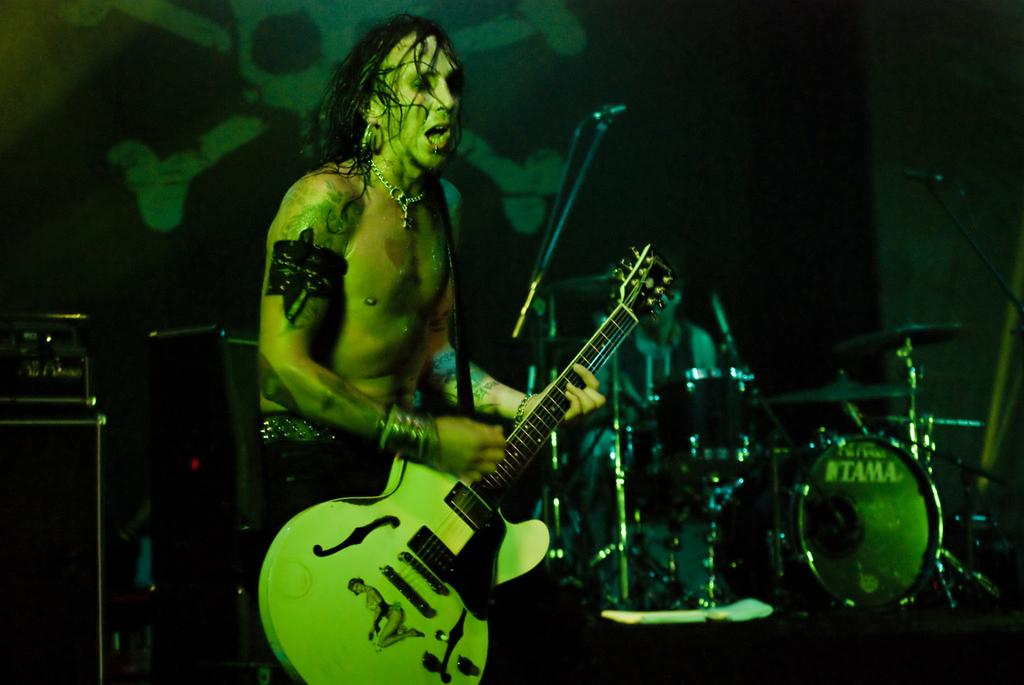What is the man in the image doing? The man in the image is playing a guitar. Are there any other people in the image? Yes, there are people in the image playing musical instruments. What can be seen in the background of the image? There is a hoarding in the image. What type of war is depicted in the image? There is no war depicted in the image; it features people playing musical instruments. Can you describe the argument between the people in the image? There is no argument depicted in the image; the people are playing music together. 